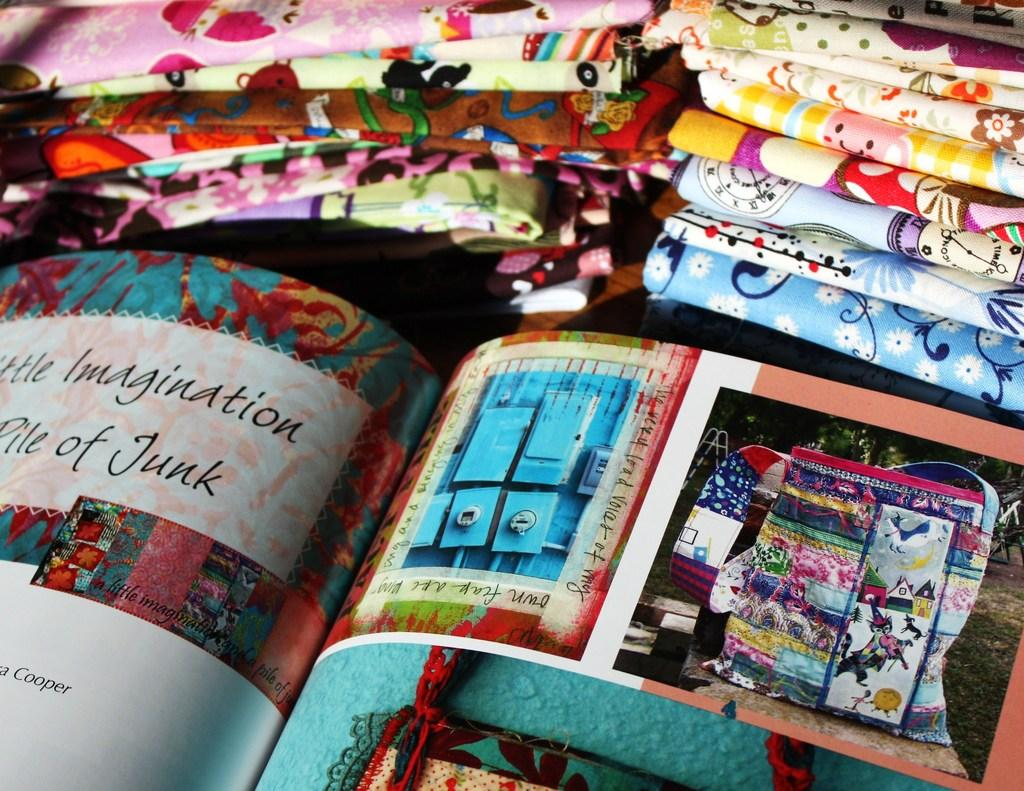<image>
Present a compact description of the photo's key features. A book is open to a page about using one's imagination when faced with a pile of junk. 